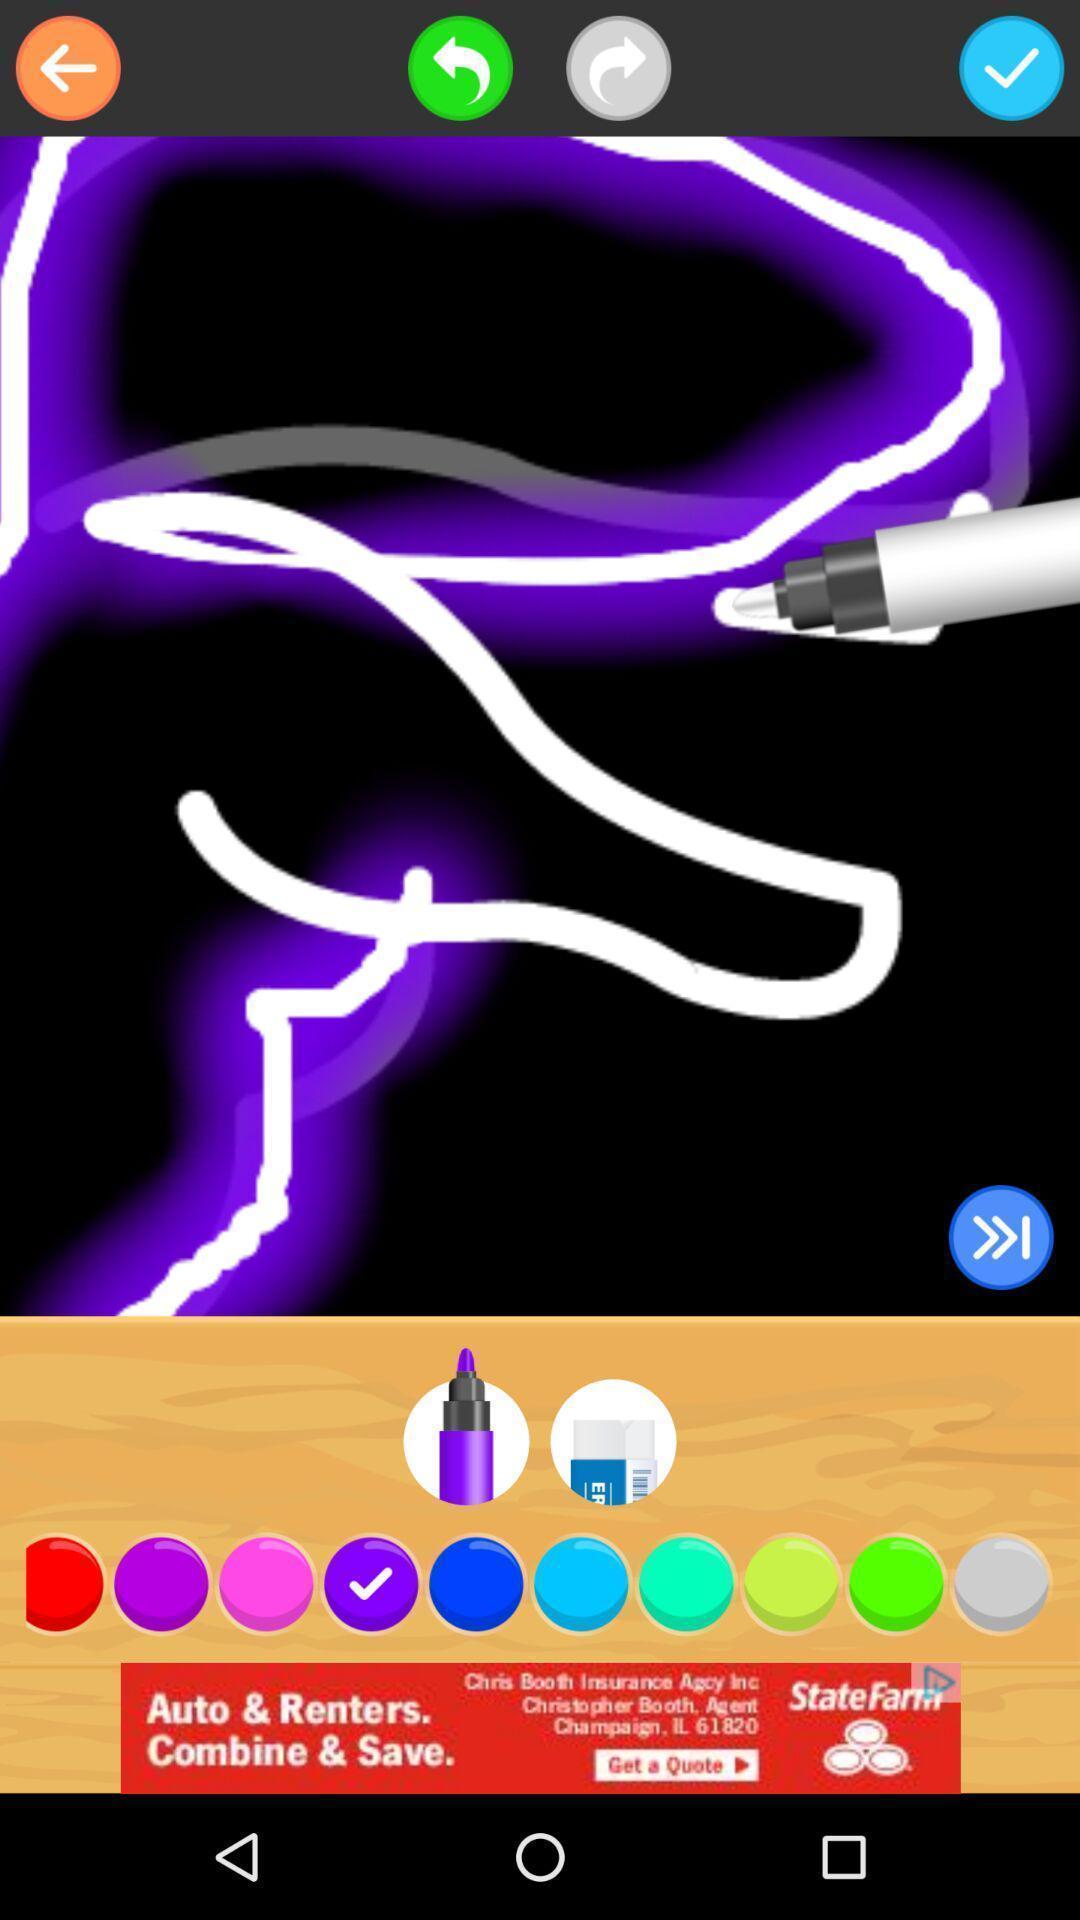Tell me what you see in this picture. Screen displaying the painting app with different features. 